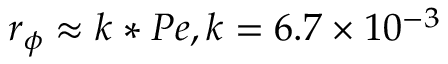<formula> <loc_0><loc_0><loc_500><loc_500>{ r _ { \phi } } \approx k * P e k = 6 . 7 \times { 1 0 ^ { - 3 } }</formula> 